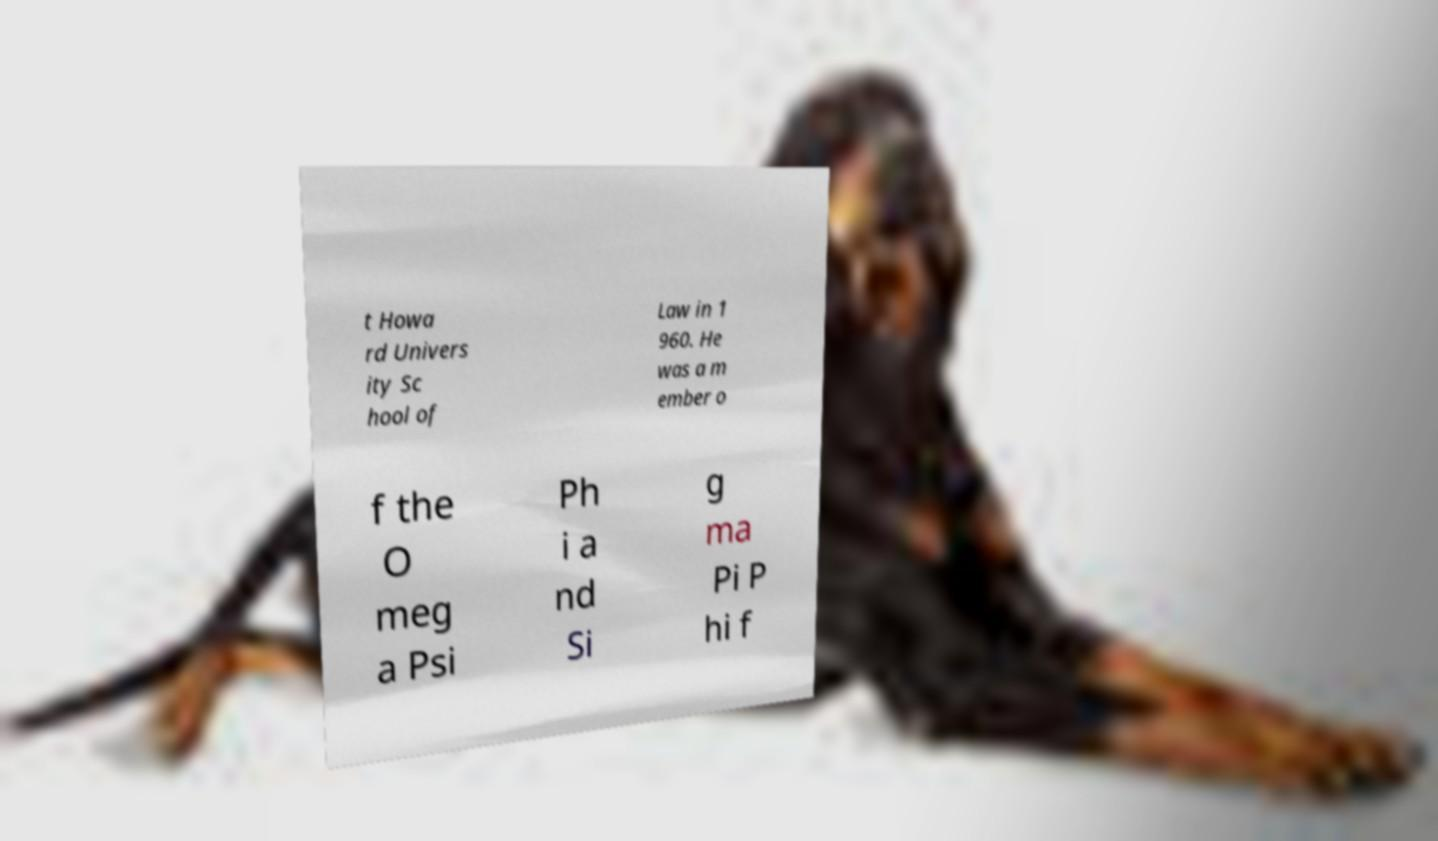Can you accurately transcribe the text from the provided image for me? t Howa rd Univers ity Sc hool of Law in 1 960. He was a m ember o f the O meg a Psi Ph i a nd Si g ma Pi P hi f 